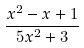<formula> <loc_0><loc_0><loc_500><loc_500>\frac { x ^ { 2 } - x + 1 } { 5 x ^ { 2 } + 3 }</formula> 